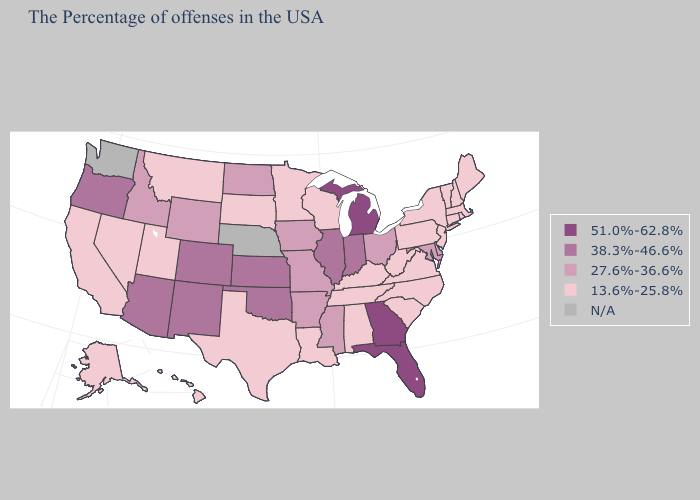Does Arizona have the lowest value in the USA?
Short answer required. No. Among the states that border Arizona , which have the highest value?
Quick response, please. Colorado, New Mexico. Which states have the highest value in the USA?
Quick response, please. Florida, Georgia, Michigan. Name the states that have a value in the range 51.0%-62.8%?
Keep it brief. Florida, Georgia, Michigan. Name the states that have a value in the range N/A?
Quick response, please. Nebraska, Washington. Does the map have missing data?
Write a very short answer. Yes. Name the states that have a value in the range 27.6%-36.6%?
Quick response, please. Delaware, Maryland, Ohio, Mississippi, Missouri, Arkansas, Iowa, North Dakota, Wyoming, Idaho. Which states have the highest value in the USA?
Answer briefly. Florida, Georgia, Michigan. What is the highest value in the MidWest ?
Answer briefly. 51.0%-62.8%. What is the value of Louisiana?
Keep it brief. 13.6%-25.8%. Does Georgia have the lowest value in the USA?
Keep it brief. No. Name the states that have a value in the range 13.6%-25.8%?
Write a very short answer. Maine, Massachusetts, Rhode Island, New Hampshire, Vermont, Connecticut, New York, New Jersey, Pennsylvania, Virginia, North Carolina, South Carolina, West Virginia, Kentucky, Alabama, Tennessee, Wisconsin, Louisiana, Minnesota, Texas, South Dakota, Utah, Montana, Nevada, California, Alaska, Hawaii. Is the legend a continuous bar?
Give a very brief answer. No. Among the states that border Kansas , does Oklahoma have the lowest value?
Answer briefly. No. 